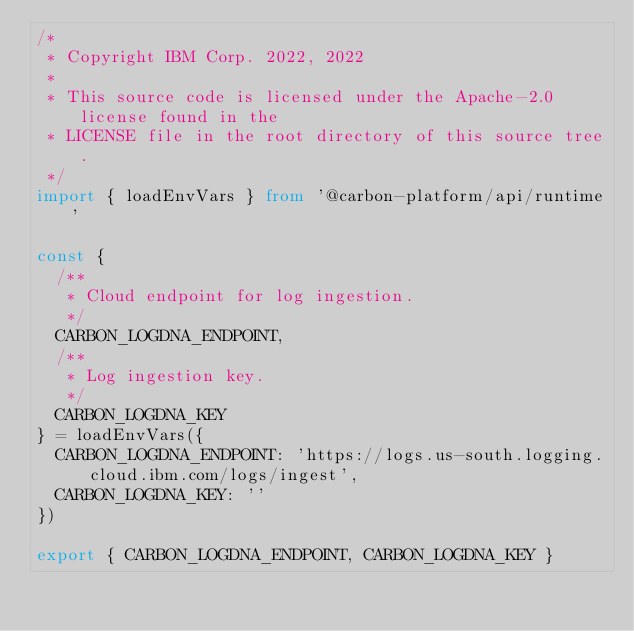Convert code to text. <code><loc_0><loc_0><loc_500><loc_500><_TypeScript_>/*
 * Copyright IBM Corp. 2022, 2022
 *
 * This source code is licensed under the Apache-2.0 license found in the
 * LICENSE file in the root directory of this source tree.
 */
import { loadEnvVars } from '@carbon-platform/api/runtime'

const {
  /**
   * Cloud endpoint for log ingestion.
   */
  CARBON_LOGDNA_ENDPOINT,
  /**
   * Log ingestion key.
   */
  CARBON_LOGDNA_KEY
} = loadEnvVars({
  CARBON_LOGDNA_ENDPOINT: 'https://logs.us-south.logging.cloud.ibm.com/logs/ingest',
  CARBON_LOGDNA_KEY: ''
})

export { CARBON_LOGDNA_ENDPOINT, CARBON_LOGDNA_KEY }
</code> 